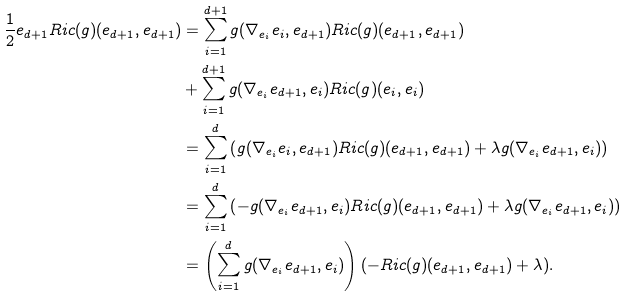Convert formula to latex. <formula><loc_0><loc_0><loc_500><loc_500>\frac { 1 } { 2 } e _ { d + 1 } R i c ( g ) ( e _ { d + 1 } , e _ { d + 1 } ) & = \sum _ { i = 1 } ^ { d + 1 } g ( \nabla _ { e _ { i } } e _ { i } , e _ { d + 1 } ) R i c ( g ) ( e _ { d + 1 } , e _ { d + 1 } ) \\ & + \sum _ { i = 1 } ^ { d + 1 } g ( \nabla _ { e _ { i } } e _ { d + 1 } , e _ { i } ) R i c ( g ) ( e _ { i } , e _ { i } ) \\ & = \sum _ { i = 1 } ^ { d } \left ( g ( \nabla _ { e _ { i } } e _ { i } , e _ { d + 1 } ) R i c ( g ) ( e _ { d + 1 } , e _ { d + 1 } ) + \lambda g ( \nabla _ { e _ { i } } e _ { d + 1 } , e _ { i } ) \right ) \\ & = \sum _ { i = 1 } ^ { d } \left ( - g ( \nabla _ { e _ { i } } e _ { d + 1 } , e _ { i } ) R i c ( g ) ( e _ { d + 1 } , e _ { d + 1 } ) + \lambda g ( \nabla _ { e _ { i } } e _ { d + 1 } , e _ { i } ) \right ) \\ & = \left ( \sum _ { i = 1 } ^ { d } g ( \nabla _ { e _ { i } } e _ { d + 1 } , e _ { i } ) \right ) ( - R i c ( g ) ( e _ { d + 1 } , e _ { d + 1 } ) + \lambda ) .</formula> 